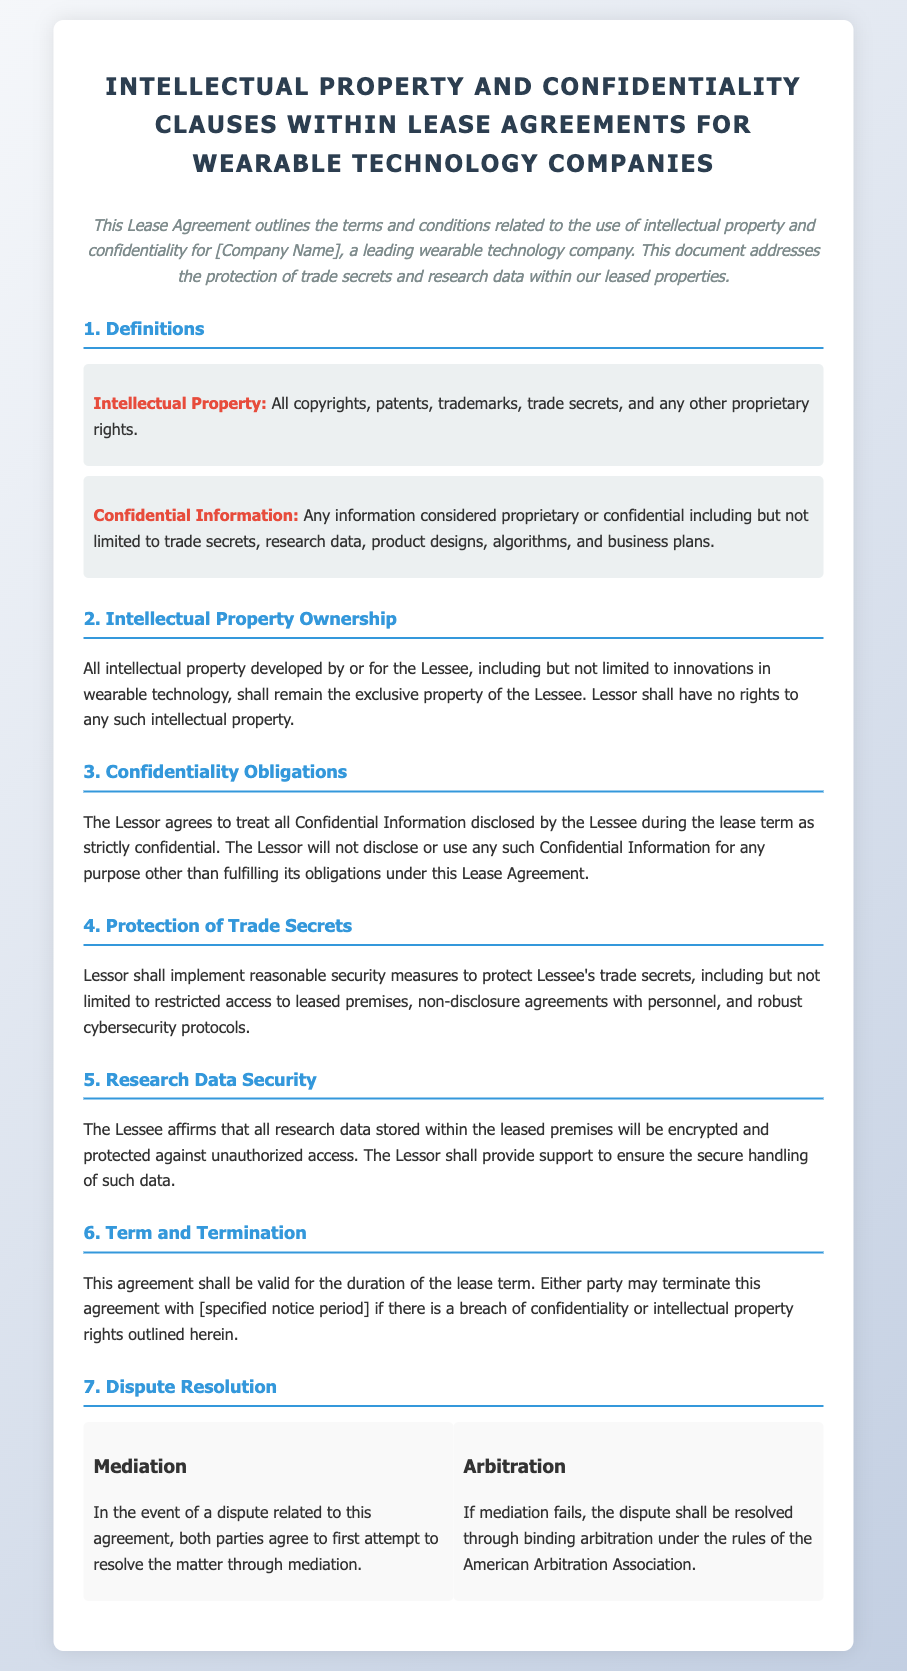What is the definition of Intellectual Property? The definition of Intellectual Property is stated in section 1 of the document, encompassing all copyrights, patents, trademarks, trade secrets, and any other proprietary rights.
Answer: All copyrights, patents, trademarks, trade secrets, and any other proprietary rights What should the Lessor do to protect Lessee's trade secrets? Section 4 outlines that the Lessor must implement reasonable security measures, including restricted access to leased premises, non-disclosure agreements with personnel, and robust cybersecurity protocols.
Answer: Implement reasonable security measures What information is considered Confidential Information? The document elaborates on Confidential Information in section 1, which includes trade secrets, research data, product designs, algorithms, and business plans.
Answer: Trade secrets, research data, product designs, algorithms, and business plans What happens if there is a breach of confidentiality? Section 6 mentions that either party may terminate the agreement if there is a breach of confidentiality or intellectual property rights.
Answer: Terminate the agreement What kind of agreement is outlined in this document? The document is a Lease Agreement specifically addressing Intellectual Property and Confidentiality Clauses for wearable technology companies.
Answer: Lease Agreement 